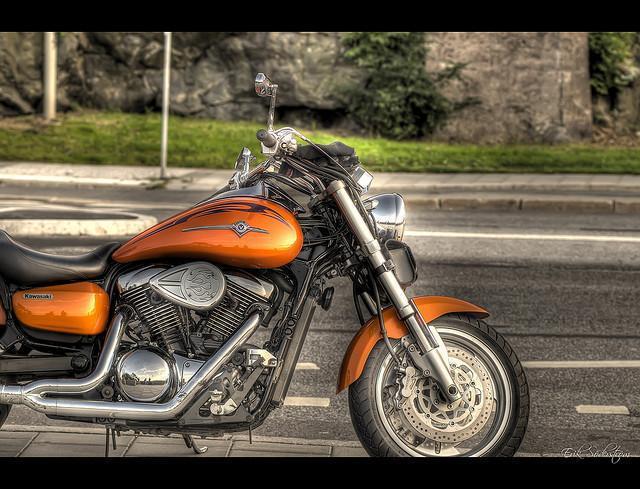How many zebras are there in this picture?
Give a very brief answer. 0. 